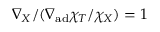<formula> <loc_0><loc_0><loc_500><loc_500>\nabla _ { X } / ( \nabla _ { a d } \chi _ { T } / \chi _ { X } ) = 1</formula> 